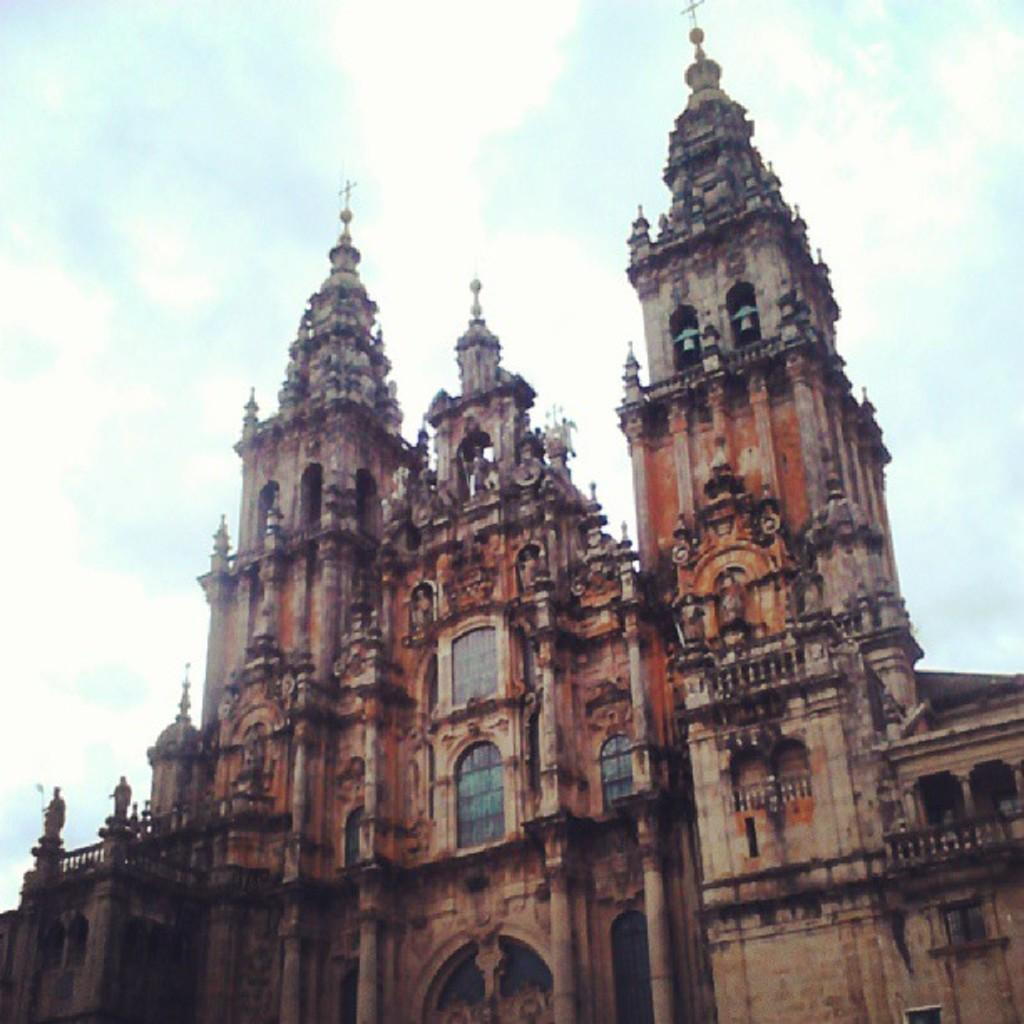What type of structure is in the image? There is a historical building in the image. What is happening to the building? The building is under construction. What architectural feature can be seen on the building? There are windows on the building. What is visible in the background of the image? The sky is visible in the image. What can be observed in the sky? Clouds are present in the sky. How many snails can be seen crawling on the building in the image? There are no snails present in the image; it features a historical building under construction. What time of day is depicted in the image, given the presence of the zebra? There is no zebra present in the image, and therefore no indication of the time of day. 